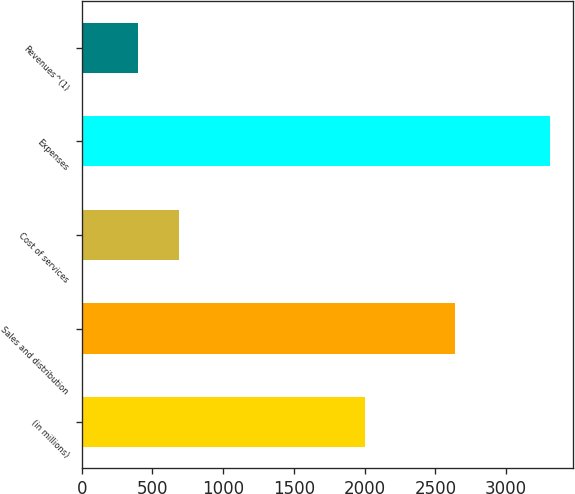Convert chart. <chart><loc_0><loc_0><loc_500><loc_500><bar_chart><fcel>(in millions)<fcel>Sales and distribution<fcel>Cost of services<fcel>Expenses<fcel>Revenues^(1)<nl><fcel>2006<fcel>2638<fcel>689.3<fcel>3311<fcel>398<nl></chart> 